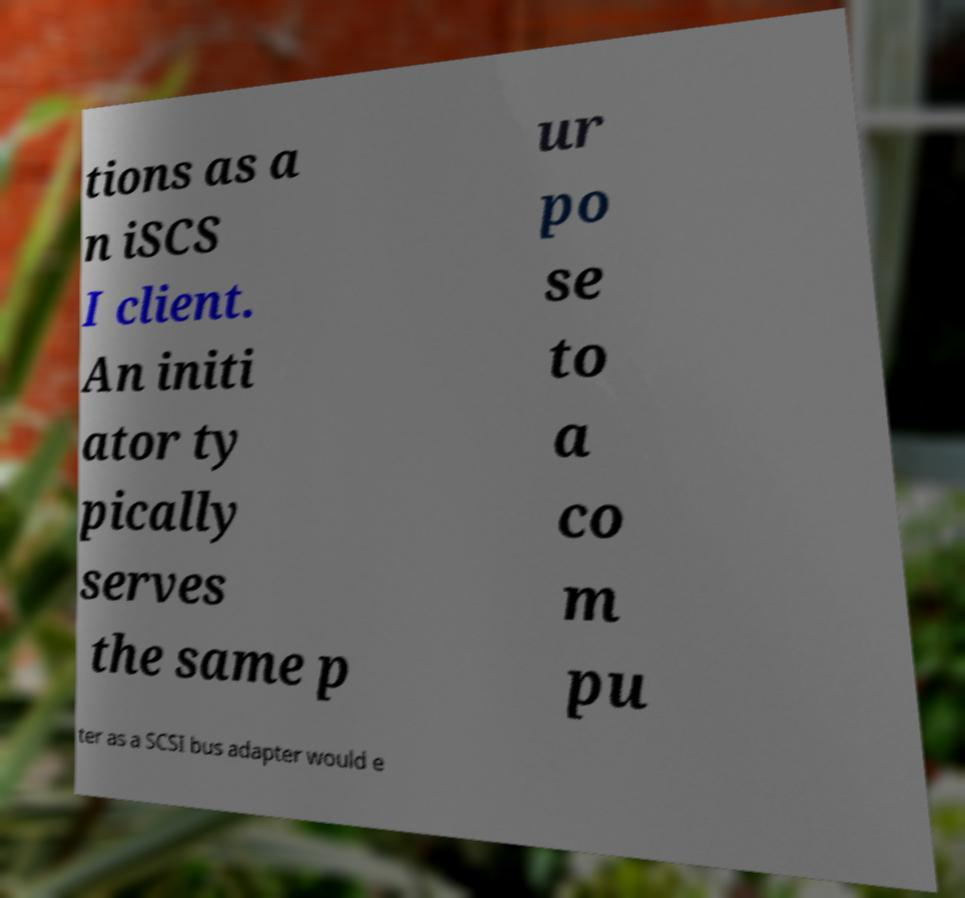Please read and relay the text visible in this image. What does it say? tions as a n iSCS I client. An initi ator ty pically serves the same p ur po se to a co m pu ter as a SCSI bus adapter would e 